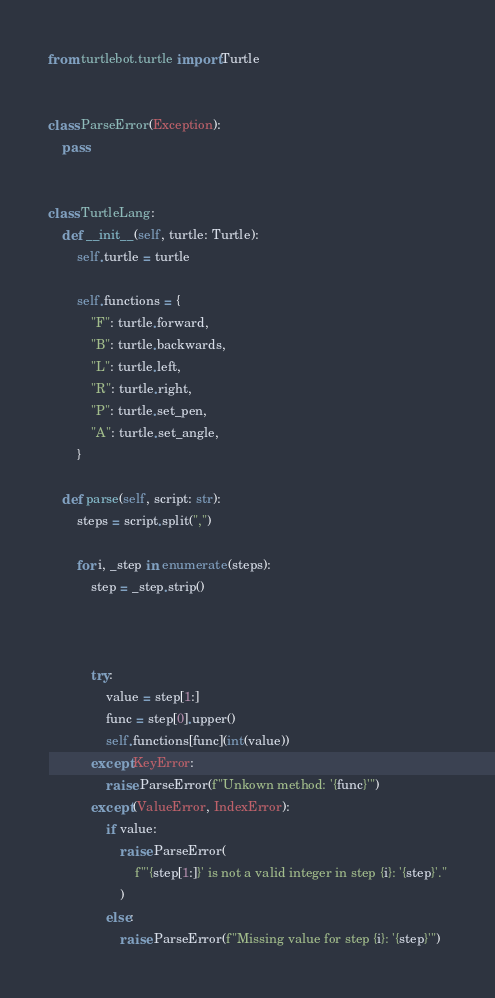Convert code to text. <code><loc_0><loc_0><loc_500><loc_500><_Python_>from turtlebot.turtle import Turtle


class ParseError(Exception):
    pass


class TurtleLang:
    def __init__(self, turtle: Turtle):
        self.turtle = turtle

        self.functions = {
            "F": turtle.forward,
            "B": turtle.backwards,
            "L": turtle.left,
            "R": turtle.right,
            "P": turtle.set_pen,
            "A": turtle.set_angle,
        }

    def parse(self, script: str):
        steps = script.split(",")

        for i, _step in enumerate(steps):
            step = _step.strip()

            

            try:
                value = step[1:]
                func = step[0].upper()
                self.functions[func](int(value))
            except KeyError:
                raise ParseError(f"Unkown method: '{func}'")
            except (ValueError, IndexError):
                if value:
                    raise ParseError(
                        f"'{step[1:]}' is not a valid integer in step {i}: '{step}'."
                    )
                else:
                    raise ParseError(f"Missing value for step {i}: '{step}'")
</code> 